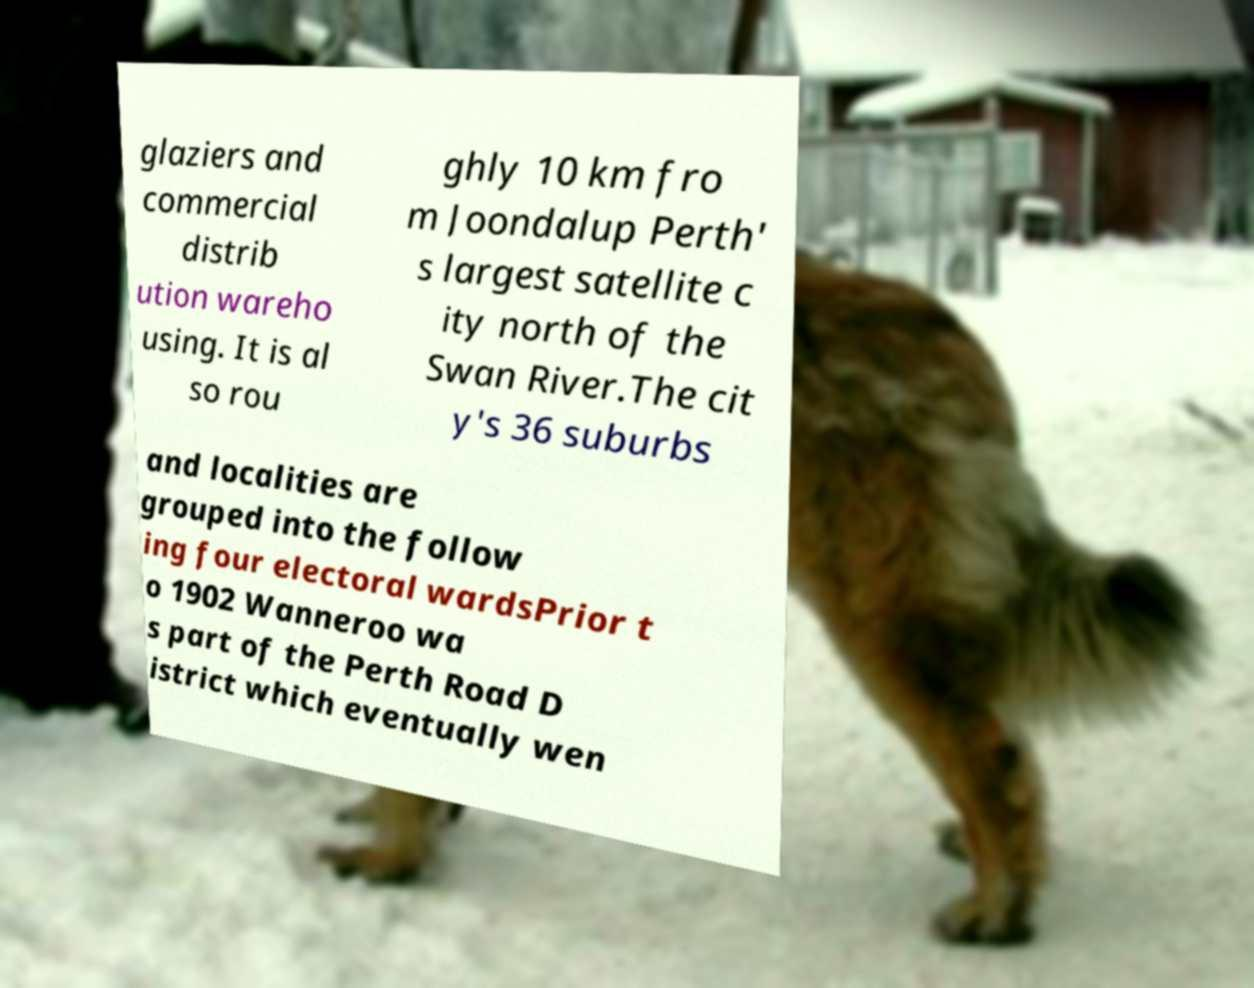Can you accurately transcribe the text from the provided image for me? glaziers and commercial distrib ution wareho using. It is al so rou ghly 10 km fro m Joondalup Perth' s largest satellite c ity north of the Swan River.The cit y's 36 suburbs and localities are grouped into the follow ing four electoral wardsPrior t o 1902 Wanneroo wa s part of the Perth Road D istrict which eventually wen 